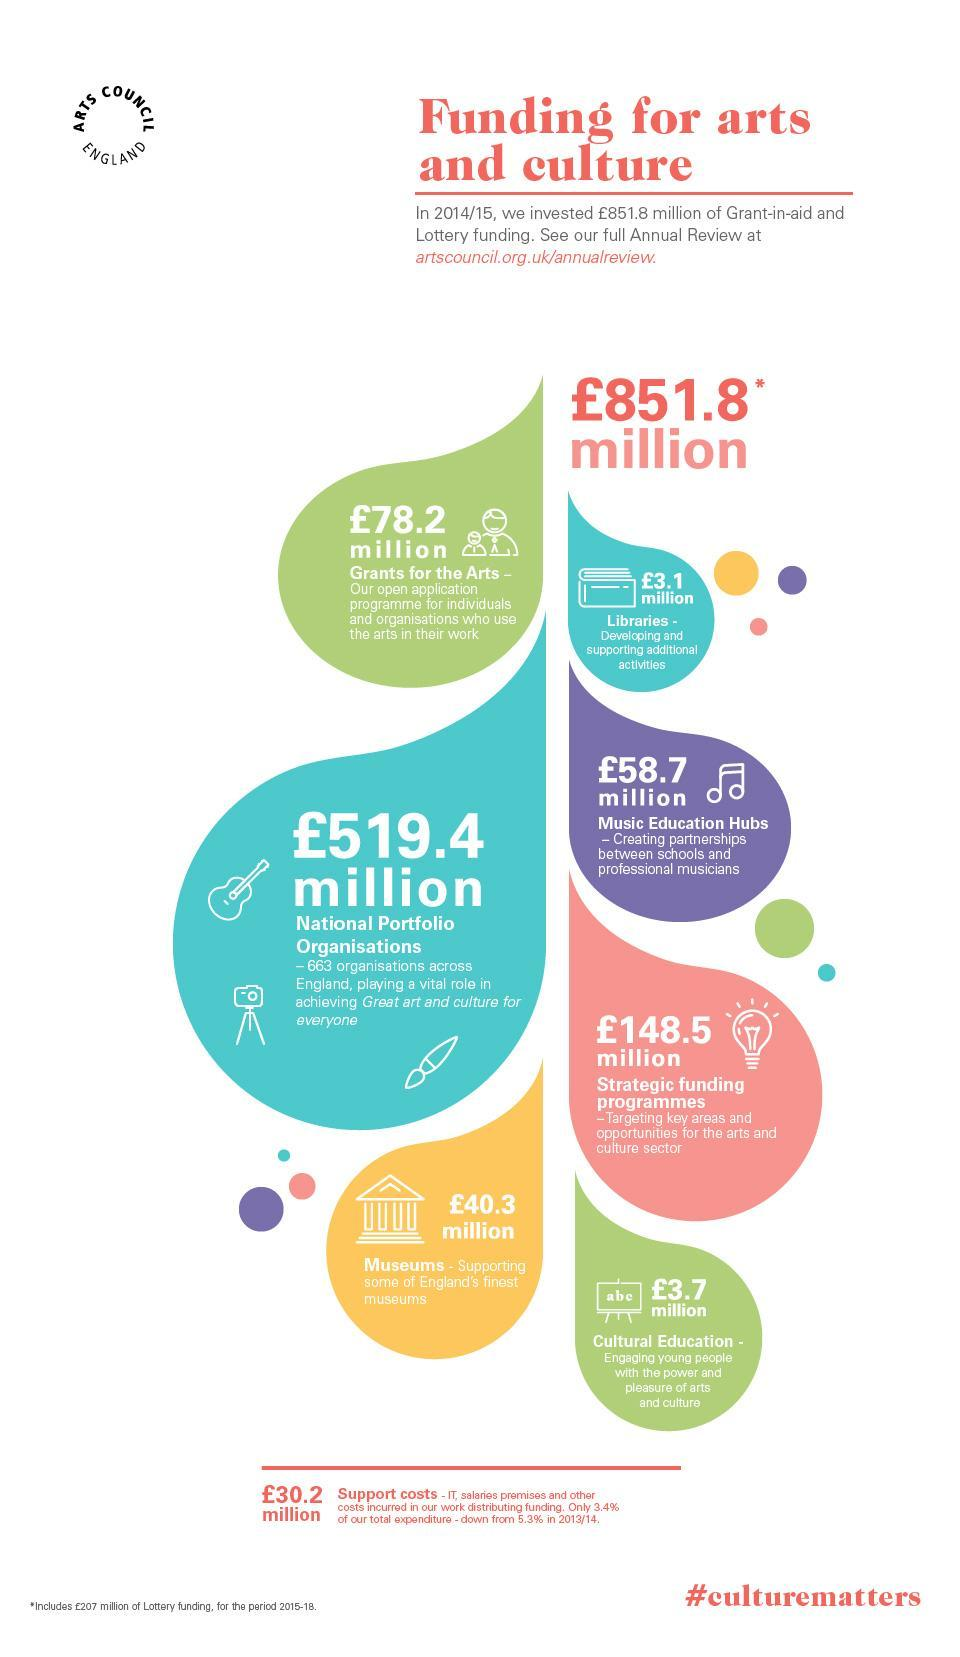Who has received the most amount in grants?
Answer the question with a short phrase. National Portfolio Organisations What is the hashtag given? #culturematters 